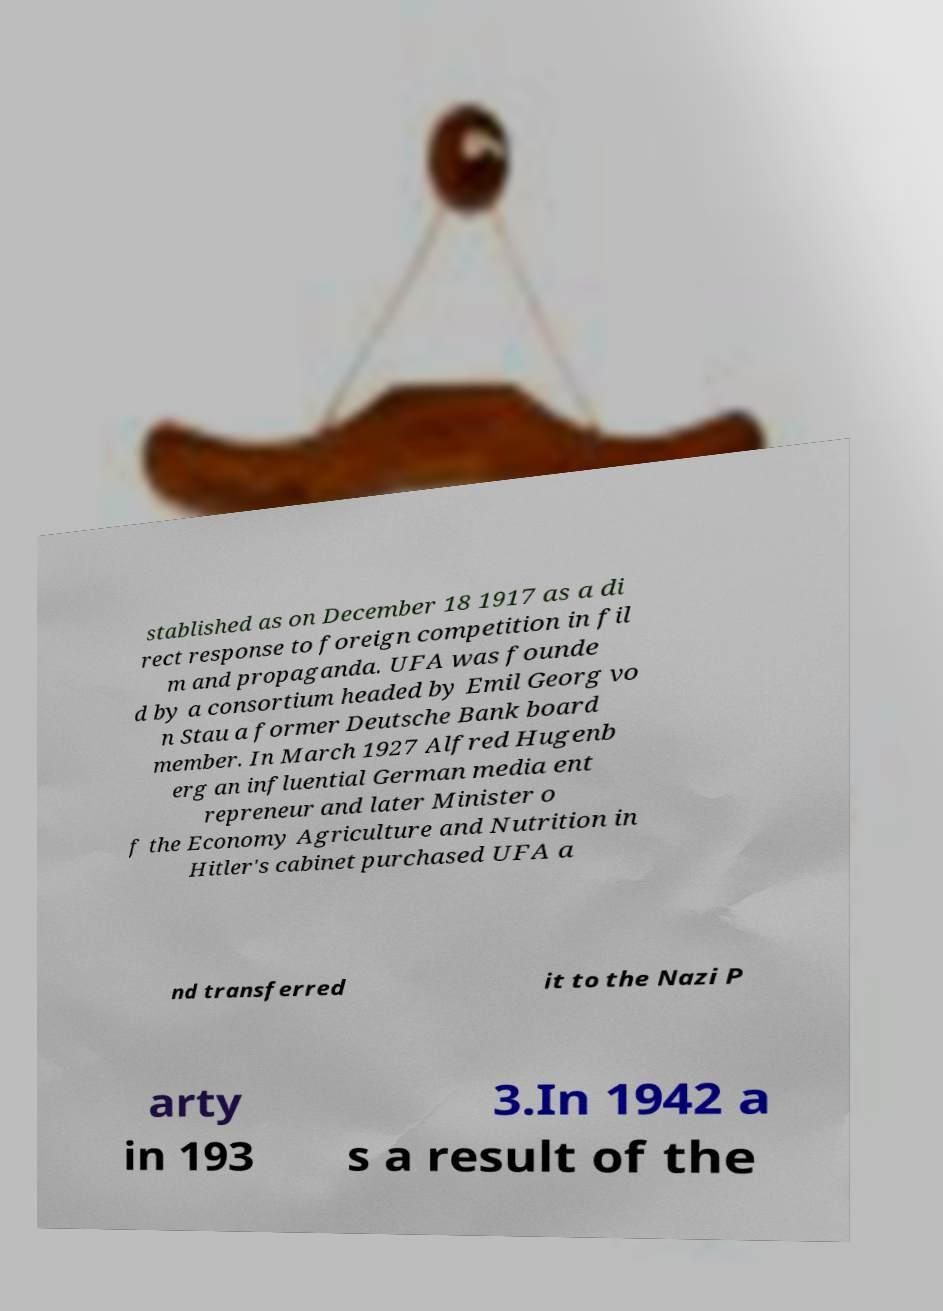Please identify and transcribe the text found in this image. stablished as on December 18 1917 as a di rect response to foreign competition in fil m and propaganda. UFA was founde d by a consortium headed by Emil Georg vo n Stau a former Deutsche Bank board member. In March 1927 Alfred Hugenb erg an influential German media ent repreneur and later Minister o f the Economy Agriculture and Nutrition in Hitler's cabinet purchased UFA a nd transferred it to the Nazi P arty in 193 3.In 1942 a s a result of the 